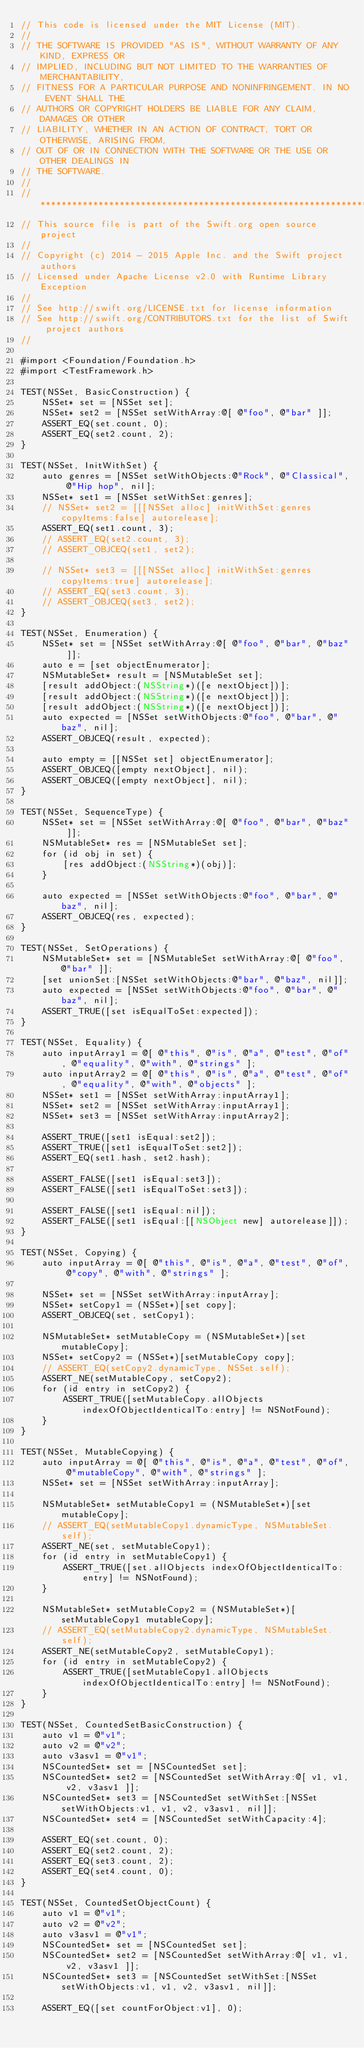<code> <loc_0><loc_0><loc_500><loc_500><_ObjectiveC_>// This code is licensed under the MIT License (MIT).
//
// THE SOFTWARE IS PROVIDED "AS IS", WITHOUT WARRANTY OF ANY KIND, EXPRESS OR
// IMPLIED, INCLUDING BUT NOT LIMITED TO THE WARRANTIES OF MERCHANTABILITY,
// FITNESS FOR A PARTICULAR PURPOSE AND NONINFRINGEMENT. IN NO EVENT SHALL THE
// AUTHORS OR COPYRIGHT HOLDERS BE LIABLE FOR ANY CLAIM, DAMAGES OR OTHER
// LIABILITY, WHETHER IN AN ACTION OF CONTRACT, TORT OR OTHERWISE, ARISING FROM,
// OUT OF OR IN CONNECTION WITH THE SOFTWARE OR THE USE OR OTHER DEALINGS IN
// THE SOFTWARE.
//
//******************************************************************************
// This source file is part of the Swift.org open source project
//
// Copyright (c) 2014 - 2015 Apple Inc. and the Swift project authors
// Licensed under Apache License v2.0 with Runtime Library Exception
//
// See http://swift.org/LICENSE.txt for license information
// See http://swift.org/CONTRIBUTORS.txt for the list of Swift project authors
//

#import <Foundation/Foundation.h>
#import <TestFramework.h>

TEST(NSSet, BasicConstruction) {
    NSSet* set = [NSSet set];
    NSSet* set2 = [NSSet setWithArray:@[ @"foo", @"bar" ]];
    ASSERT_EQ(set.count, 0);
    ASSERT_EQ(set2.count, 2);
}

TEST(NSSet, InitWithSet) {
    auto genres = [NSSet setWithObjects:@"Rock", @"Classical", @"Hip hop", nil];
    NSSet* set1 = [NSSet setWithSet:genres];
    // NSSet* set2 = [[[NSSet alloc] initWithSet:genres copyItems:false] autorelease];
    ASSERT_EQ(set1.count, 3);
    // ASSERT_EQ(set2.count, 3);
    // ASSERT_OBJCEQ(set1, set2);

    // NSSet* set3 = [[[NSSet alloc] initWithSet:genres copyItems:true] autorelease];
    // ASSERT_EQ(set3.count, 3);
    // ASSERT_OBJCEQ(set3, set2);
}

TEST(NSSet, Enumeration) {
    NSSet* set = [NSSet setWithArray:@[ @"foo", @"bar", @"baz" ]];
    auto e = [set objectEnumerator];
    NSMutableSet* result = [NSMutableSet set];
    [result addObject:(NSString*)([e nextObject])];
    [result addObject:(NSString*)([e nextObject])];
    [result addObject:(NSString*)([e nextObject])];
    auto expected = [NSSet setWithObjects:@"foo", @"bar", @"baz", nil];
    ASSERT_OBJCEQ(result, expected);

    auto empty = [[NSSet set] objectEnumerator];
    ASSERT_OBJCEQ([empty nextObject], nil);
    ASSERT_OBJCEQ([empty nextObject], nil);
}

TEST(NSSet, SequenceType) {
    NSSet* set = [NSSet setWithArray:@[ @"foo", @"bar", @"baz" ]];
    NSMutableSet* res = [NSMutableSet set];
    for (id obj in set) {
        [res addObject:(NSString*)(obj)];
    }

    auto expected = [NSSet setWithObjects:@"foo", @"bar", @"baz", nil];
    ASSERT_OBJCEQ(res, expected);
}

TEST(NSSet, SetOperations) {
    NSMutableSet* set = [NSMutableSet setWithArray:@[ @"foo", @"bar" ]];
    [set unionSet:[NSSet setWithObjects:@"bar", @"baz", nil]];
    auto expected = [NSSet setWithObjects:@"foo", @"bar", @"baz", nil];
    ASSERT_TRUE([set isEqualToSet:expected]);
}

TEST(NSSet, Equality) {
    auto inputArray1 = @[ @"this", @"is", @"a", @"test", @"of", @"equality", @"with", @"strings" ];
    auto inputArray2 = @[ @"this", @"is", @"a", @"test", @"of", @"equality", @"with", @"objects" ];
    NSSet* set1 = [NSSet setWithArray:inputArray1];
    NSSet* set2 = [NSSet setWithArray:inputArray1];
    NSSet* set3 = [NSSet setWithArray:inputArray2];

    ASSERT_TRUE([set1 isEqual:set2]);
    ASSERT_TRUE([set1 isEqualToSet:set2]);
    ASSERT_EQ(set1.hash, set2.hash);

    ASSERT_FALSE([set1 isEqual:set3]);
    ASSERT_FALSE([set1 isEqualToSet:set3]);

    ASSERT_FALSE([set1 isEqual:nil]);
    ASSERT_FALSE([set1 isEqual:[[NSObject new] autorelease]]);
}

TEST(NSSet, Copying) {
    auto inputArray = @[ @"this", @"is", @"a", @"test", @"of", @"copy", @"with", @"strings" ];

    NSSet* set = [NSSet setWithArray:inputArray];
    NSSet* setCopy1 = (NSSet*)[set copy];
    ASSERT_OBJCEQ(set, setCopy1);

    NSMutableSet* setMutableCopy = (NSMutableSet*)[set mutableCopy];
    NSSet* setCopy2 = (NSSet*)[setMutableCopy copy];
    // ASSERT_EQ(setCopy2.dynamicType, NSSet.self);
    ASSERT_NE(setMutableCopy, setCopy2);
    for (id entry in setCopy2) {
        ASSERT_TRUE([setMutableCopy.allObjects indexOfObjectIdenticalTo:entry] != NSNotFound);
    }
}

TEST(NSSet, MutableCopying) {
    auto inputArray = @[ @"this", @"is", @"a", @"test", @"of", @"mutableCopy", @"with", @"strings" ];
    NSSet* set = [NSSet setWithArray:inputArray];

    NSMutableSet* setMutableCopy1 = (NSMutableSet*)[set mutableCopy];
    // ASSERT_EQ(setMutableCopy1.dynamicType, NSMutableSet.self);
    ASSERT_NE(set, setMutableCopy1);
    for (id entry in setMutableCopy1) {
        ASSERT_TRUE([set.allObjects indexOfObjectIdenticalTo:entry] != NSNotFound);
    }

    NSMutableSet* setMutableCopy2 = (NSMutableSet*)[setMutableCopy1 mutableCopy];
    // ASSERT_EQ(setMutableCopy2.dynamicType, NSMutableSet.self);
    ASSERT_NE(setMutableCopy2, setMutableCopy1);
    for (id entry in setMutableCopy2) {
        ASSERT_TRUE([setMutableCopy1.allObjects indexOfObjectIdenticalTo:entry] != NSNotFound);
    }
}

TEST(NSSet, CountedSetBasicConstruction) {
    auto v1 = @"v1";
    auto v2 = @"v2";
    auto v3asv1 = @"v1";
    NSCountedSet* set = [NSCountedSet set];
    NSCountedSet* set2 = [NSCountedSet setWithArray:@[ v1, v1, v2, v3asv1 ]];
    NSCountedSet* set3 = [NSCountedSet setWithSet:[NSSet setWithObjects:v1, v1, v2, v3asv1, nil]];
    NSCountedSet* set4 = [NSCountedSet setWithCapacity:4];

    ASSERT_EQ(set.count, 0);
    ASSERT_EQ(set2.count, 2);
    ASSERT_EQ(set3.count, 2);
    ASSERT_EQ(set4.count, 0);
}

TEST(NSSet, CountedSetObjectCount) {
    auto v1 = @"v1";
    auto v2 = @"v2";
    auto v3asv1 = @"v1";
    NSCountedSet* set = [NSCountedSet set];
    NSCountedSet* set2 = [NSCountedSet setWithArray:@[ v1, v1, v2, v3asv1 ]];
    NSCountedSet* set3 = [NSCountedSet setWithSet:[NSSet setWithObjects:v1, v1, v2, v3asv1, nil]];

    ASSERT_EQ([set countForObject:v1], 0);</code> 